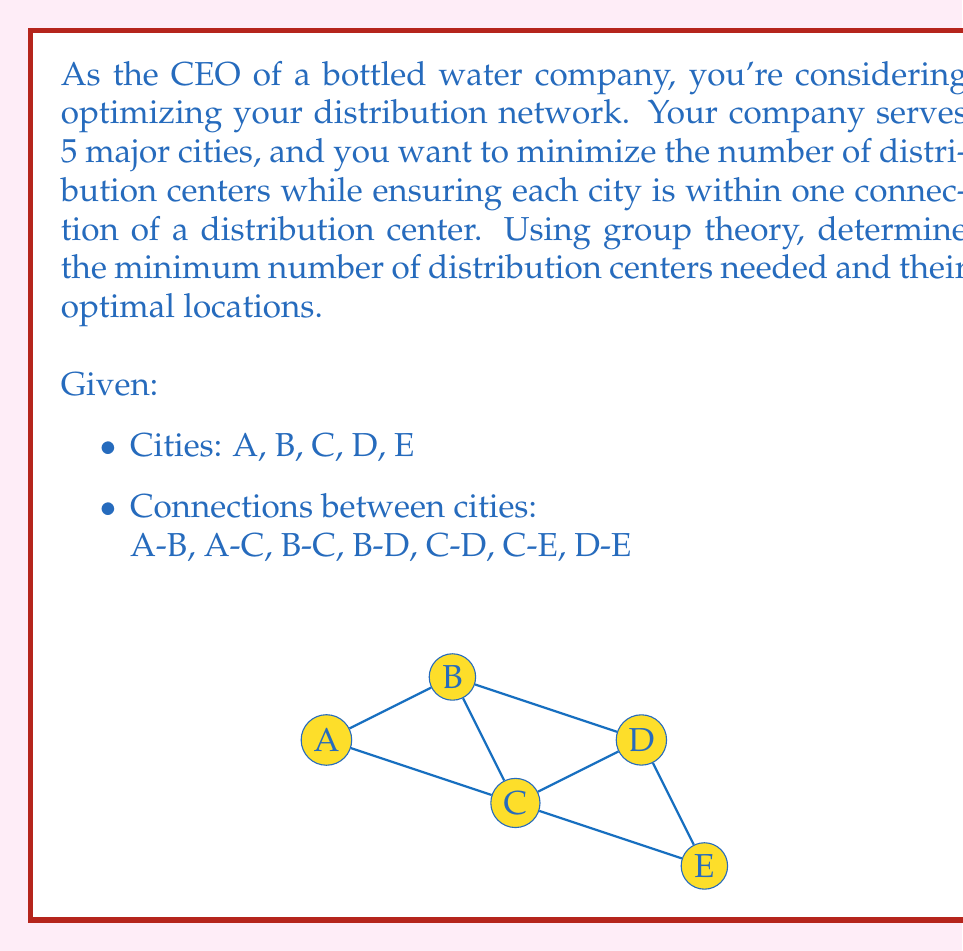Give your solution to this math problem. To solve this problem, we can use concepts from graph theory, which is closely related to abstract algebra. We'll approach this step-by-step:

1) First, we need to understand what we're looking for. We want a dominating set in the graph, where each vertex (city) is either in the set or adjacent to a vertex in the set.

2) In graph theory terms, we're looking for the minimum dominating set.

3) One way to find this is to consider the complement of each possible set and check if it's an independent set (no two vertices are adjacent).

4) Let's start with the smallest possible set size and work our way up:

   - 1 vertex: No single vertex is adjacent to all others.
   - 2 vertices: We need to check all pairs.

5) Looking at the graph, we can see that vertices C and D together are adjacent to all other vertices.

6) To prove this is minimal, we need to show that no single vertex covers all others, which is clear from the graph.

7) Therefore, the minimum dominating set consists of vertices C and D.

In terms of our original problem:
- We need a minimum of 2 distribution centers.
- These should be located in cities C and D.

This solution ensures that every city is either a distribution center itself or directly connected to one, minimizing transportation costs while maintaining efficient distribution.
Answer: 2 distribution centers, located in cities C and D. 